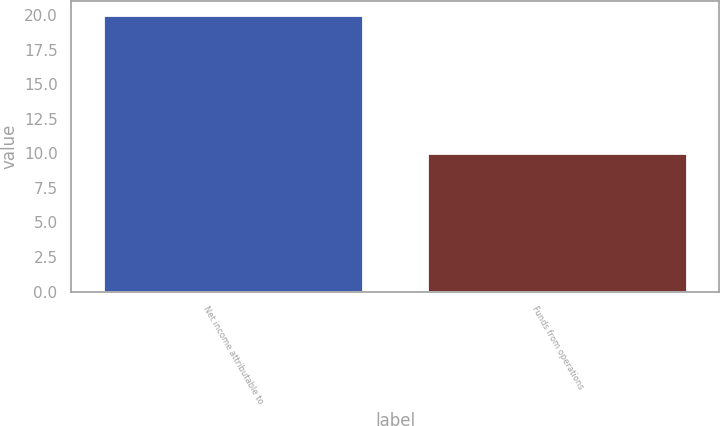Convert chart to OTSL. <chart><loc_0><loc_0><loc_500><loc_500><bar_chart><fcel>Net income attributable to<fcel>Funds from operations<nl><fcel>20<fcel>10<nl></chart> 